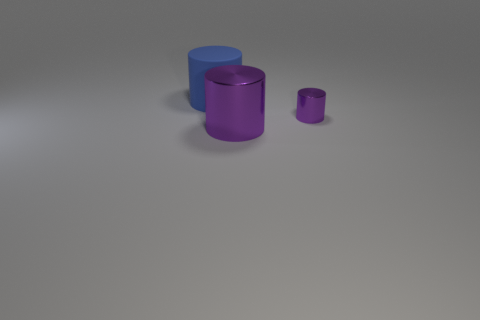Add 2 small green cubes. How many objects exist? 5 Add 3 large gray things. How many large gray things exist? 3 Subtract 0 cyan spheres. How many objects are left? 3 Subtract all tiny metallic cylinders. Subtract all big purple things. How many objects are left? 1 Add 3 metal objects. How many metal objects are left? 5 